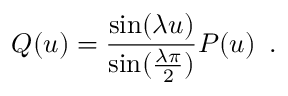Convert formula to latex. <formula><loc_0><loc_0><loc_500><loc_500>Q ( u ) = \frac { \sin ( \lambda u ) } { \sin ( \frac { \lambda \pi } { 2 } ) } P ( u ) \, .</formula> 